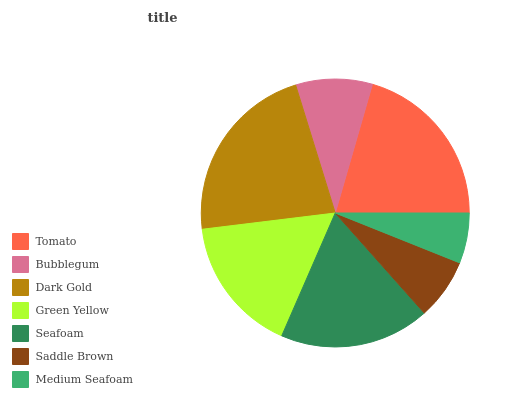Is Medium Seafoam the minimum?
Answer yes or no. Yes. Is Dark Gold the maximum?
Answer yes or no. Yes. Is Bubblegum the minimum?
Answer yes or no. No. Is Bubblegum the maximum?
Answer yes or no. No. Is Tomato greater than Bubblegum?
Answer yes or no. Yes. Is Bubblegum less than Tomato?
Answer yes or no. Yes. Is Bubblegum greater than Tomato?
Answer yes or no. No. Is Tomato less than Bubblegum?
Answer yes or no. No. Is Green Yellow the high median?
Answer yes or no. Yes. Is Green Yellow the low median?
Answer yes or no. Yes. Is Seafoam the high median?
Answer yes or no. No. Is Seafoam the low median?
Answer yes or no. No. 